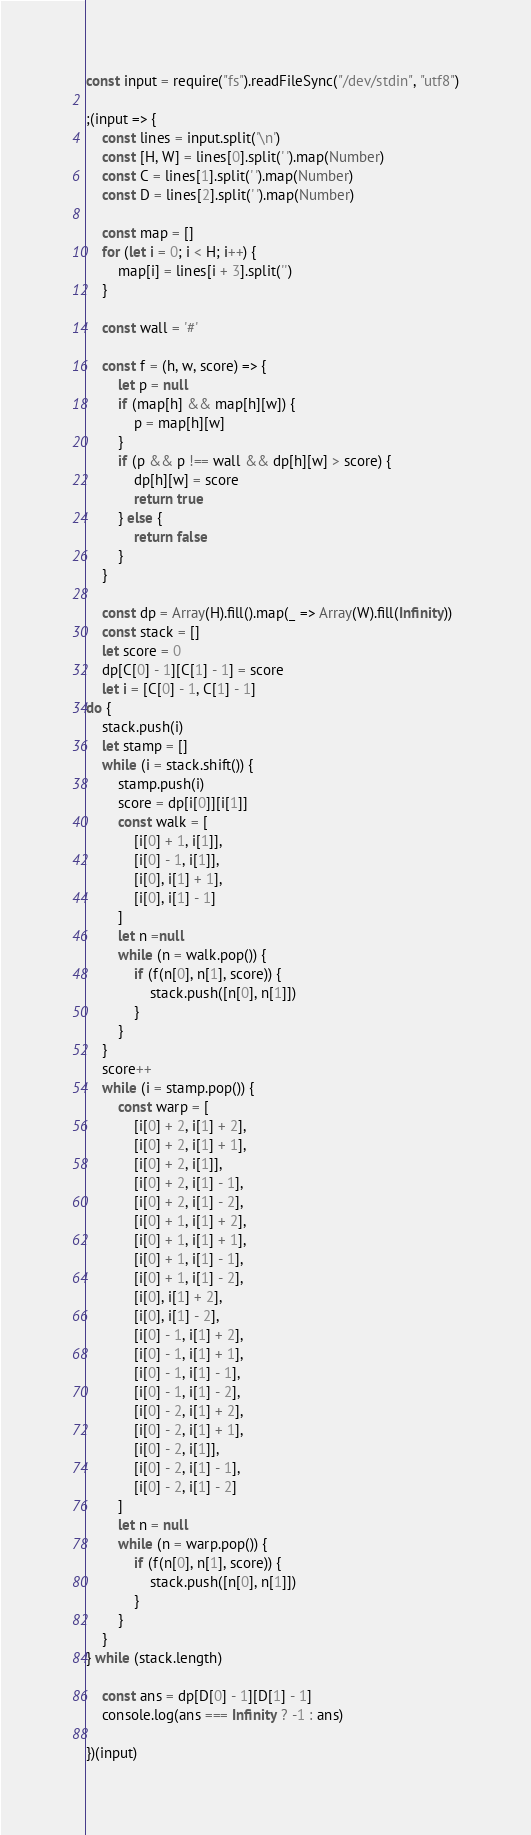<code> <loc_0><loc_0><loc_500><loc_500><_JavaScript_>const input = require("fs").readFileSync("/dev/stdin", "utf8")

;(input => {
    const lines = input.split('\n')
    const [H, W] = lines[0].split(' ').map(Number)
    const C = lines[1].split(' ').map(Number)
    const D = lines[2].split(' ').map(Number)

    const map = []
    for (let i = 0; i < H; i++) {
        map[i] = lines[i + 3].split('')
    }

    const wall = '#'

    const f = (h, w, score) => {
        let p = null
        if (map[h] && map[h][w]) {
            p = map[h][w]
        }
        if (p && p !== wall && dp[h][w] > score) {
            dp[h][w] = score
            return true
        } else {
            return false
        }
    }

    const dp = Array(H).fill().map(_ => Array(W).fill(Infinity))
    const stack = []
    let score = 0
    dp[C[0] - 1][C[1] - 1] = score
    let i = [C[0] - 1, C[1] - 1]
do {
    stack.push(i)
    let stamp = []
    while (i = stack.shift()) {
        stamp.push(i)
        score = dp[i[0]][i[1]]
        const walk = [
            [i[0] + 1, i[1]],
            [i[0] - 1, i[1]],
            [i[0], i[1] + 1],
            [i[0], i[1] - 1]
        ]
        let n =null
        while (n = walk.pop()) {
            if (f(n[0], n[1], score)) {
                stack.push([n[0], n[1]])
            }
        }
    }
    score++
    while (i = stamp.pop()) {
        const warp = [
            [i[0] + 2, i[1] + 2],
            [i[0] + 2, i[1] + 1],
            [i[0] + 2, i[1]],
            [i[0] + 2, i[1] - 1],
            [i[0] + 2, i[1] - 2],
            [i[0] + 1, i[1] + 2],
            [i[0] + 1, i[1] + 1],
            [i[0] + 1, i[1] - 1],
            [i[0] + 1, i[1] - 2],
            [i[0], i[1] + 2],
            [i[0], i[1] - 2],
            [i[0] - 1, i[1] + 2],
            [i[0] - 1, i[1] + 1],
            [i[0] - 1, i[1] - 1],
            [i[0] - 1, i[1] - 2],
            [i[0] - 2, i[1] + 2],
            [i[0] - 2, i[1] + 1],
            [i[0] - 2, i[1]],
            [i[0] - 2, i[1] - 1],
            [i[0] - 2, i[1] - 2]
        ]
        let n = null
        while (n = warp.pop()) {
            if (f(n[0], n[1], score)) {
                stack.push([n[0], n[1]])
            }
        }
    }
} while (stack.length)

    const ans = dp[D[0] - 1][D[1] - 1]
    console.log(ans === Infinity ? -1 : ans)

})(input)
</code> 